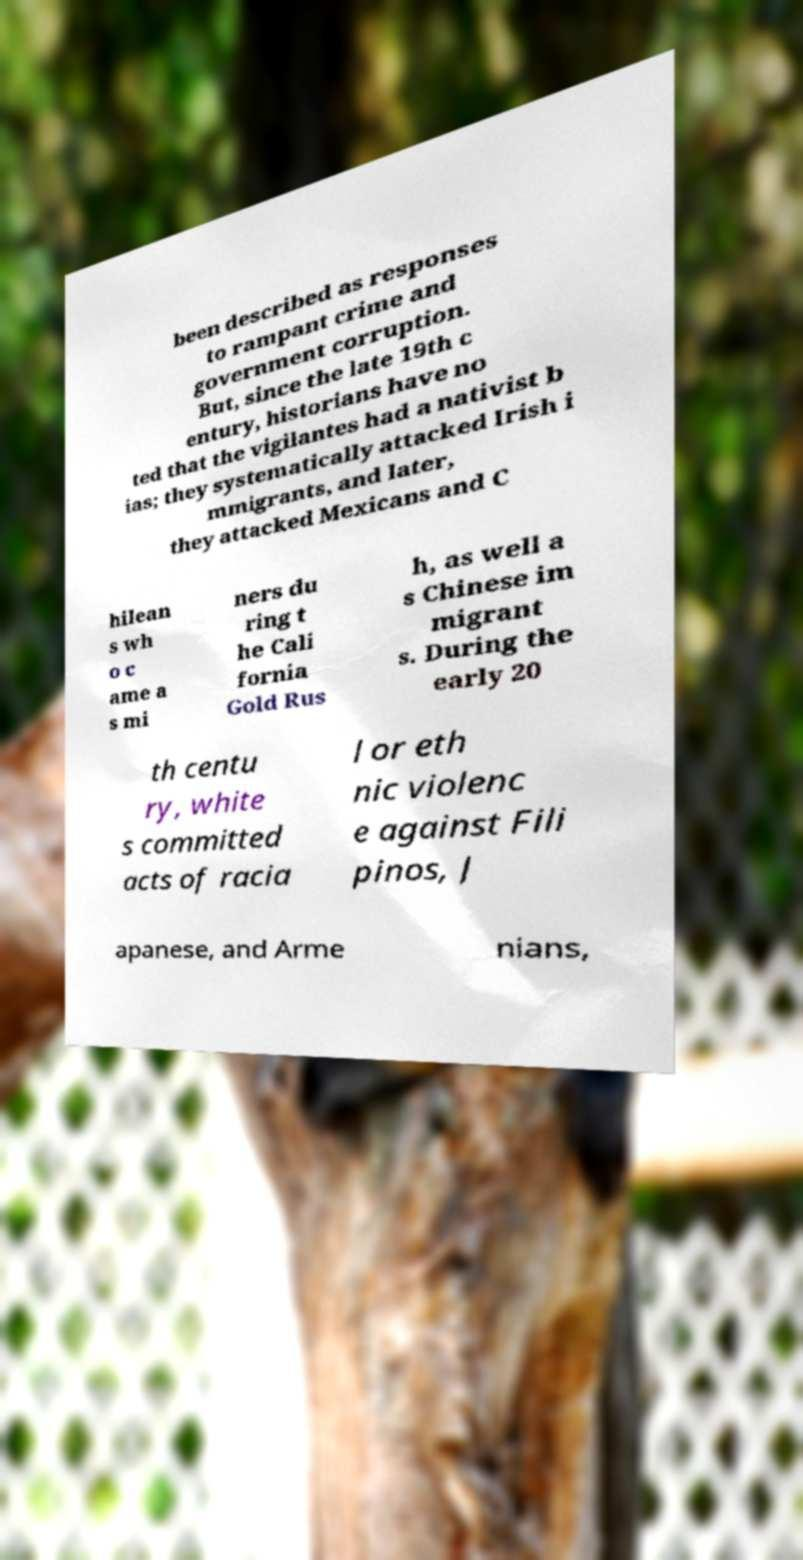There's text embedded in this image that I need extracted. Can you transcribe it verbatim? been described as responses to rampant crime and government corruption. But, since the late 19th c entury, historians have no ted that the vigilantes had a nativist b ias; they systematically attacked Irish i mmigrants, and later, they attacked Mexicans and C hilean s wh o c ame a s mi ners du ring t he Cali fornia Gold Rus h, as well a s Chinese im migrant s. During the early 20 th centu ry, white s committed acts of racia l or eth nic violenc e against Fili pinos, J apanese, and Arme nians, 